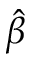<formula> <loc_0><loc_0><loc_500><loc_500>\hat { \beta }</formula> 